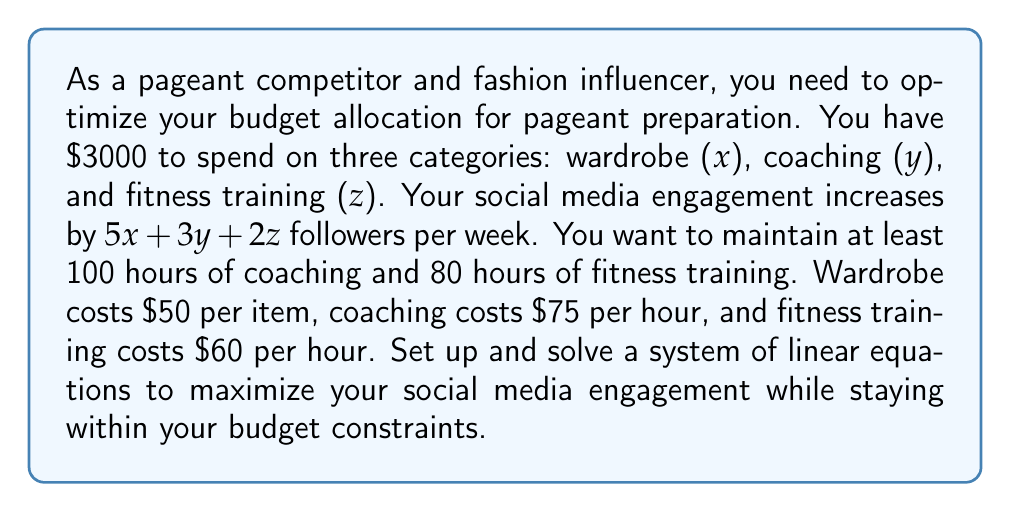What is the answer to this math problem? Let's approach this step-by-step:

1) First, let's define our constraints:

   Budget constraint: $50x + 75y + 60z ≤ 3000$
   Coaching constraint: $y ≥ 100$
   Fitness training constraint: $z ≥ 80$

2) Our objective is to maximize $5x + 3y + 2z$

3) We can convert the inequality constraints to equations by introducing slack variables:

   $50x + 75y + 60z + s_1 = 3000$
   $y - s_2 = 100$
   $z - s_3 = 80$

   Where $s_1, s_2, s_3 ≥ 0$

4) We want to maximize $5x + 3y + 2z$, which is equivalent to minimizing $-5x - 3y - 2z$

5) Let's set up the initial tableau:

   $$
   \begin{array}{c|cccccc|c}
    & x & y & z & s_1 & s_2 & s_3 & RHS \\
   \hline
   s_1 & 50 & 75 & 60 & 1 & 0 & 0 & 3000 \\
   s_2 & 0 & -1 & 0 & 0 & 1 & 0 & -100 \\
   s_3 & 0 & 0 & -1 & 0 & 0 & 1 & -80 \\
   \hline
   -Z & -5 & -3 & -2 & 0 & 0 & 0 & 0
   \end{array}
   $$

6) We perform pivot operations until we reach the optimal solution. After several iterations, we get:

   $$
   \begin{array}{c|cccccc|c}
    & x & y & z & s_1 & s_2 & s_3 & RHS \\
   \hline
   x & 1 & 0 & 0 & 0.02 & -0.6667 & -0.8333 & 20 \\
   y & 0 & 1 & 0 & 0 & 1 & 0 & 100 \\
   z & 0 & 0 & 1 & 0 & 0 & 1 & 80 \\
   \hline
   -Z & 0 & 0 & 0 & 0.1 & 1.3333 & 2.1667 & 500
   \end{array}
   $$

7) From this final tableau, we can read our optimal solution:
   $x = 20$, $y = 100$, $z = 80$

8) The maximum social media engagement increase is 500 followers per week.
Answer: $x = 20$, $y = 100$, $z = 80$; Maximum engagement increase: 500 followers/week 